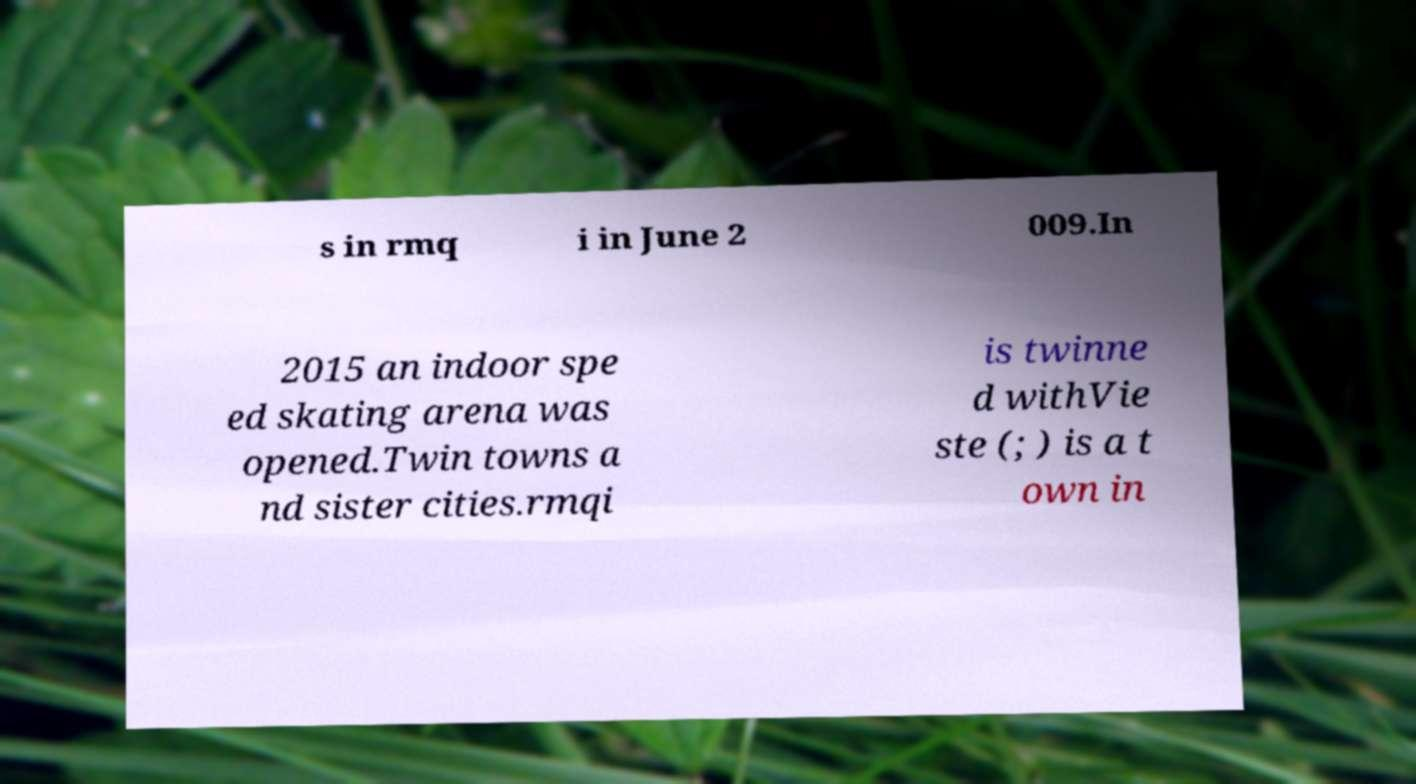Please identify and transcribe the text found in this image. s in rmq i in June 2 009.In 2015 an indoor spe ed skating arena was opened.Twin towns a nd sister cities.rmqi is twinne d withVie ste (; ) is a t own in 